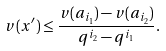<formula> <loc_0><loc_0><loc_500><loc_500>v ( x ^ { \prime } ) \leq \frac { v ( a _ { i _ { 1 } } ) - v ( a _ { i _ { 2 } } ) } { q ^ { i _ { 2 } } - q ^ { i _ { 1 } } } .</formula> 